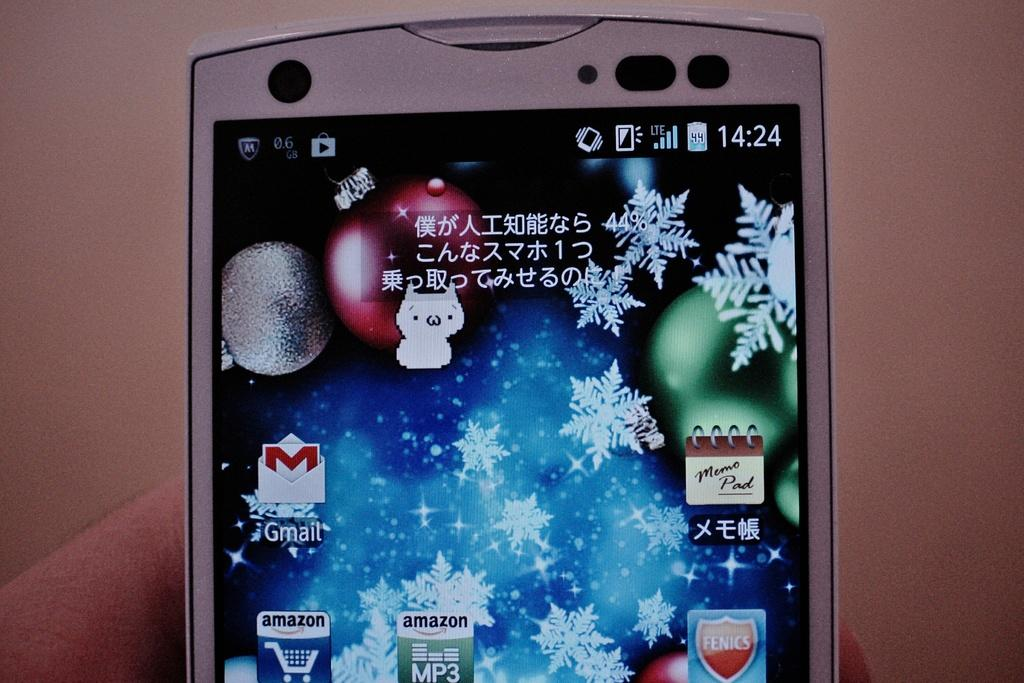What is being held in the image? A mobile is being held with fingers in the image. What part of the mobile is visible in the image? The mobile's screen is visible in the image. What color is the background of the image? The background of the image is brown. What type of beef is being cooked in the image? There is no beef present in the image; it features a mobile being held with fingers. How many hens can be seen in the image? There are no hens present in the image. 